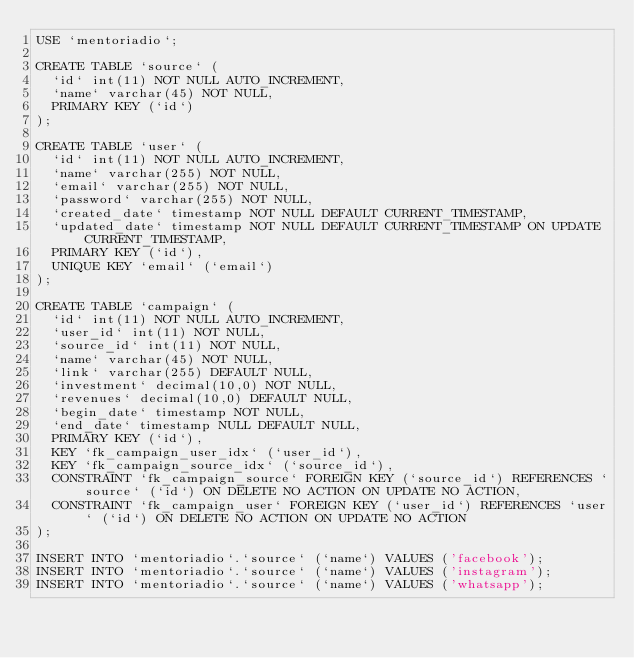Convert code to text. <code><loc_0><loc_0><loc_500><loc_500><_SQL_>USE `mentoriadio`;

CREATE TABLE `source` (
  `id` int(11) NOT NULL AUTO_INCREMENT,
  `name` varchar(45) NOT NULL,
  PRIMARY KEY (`id`)
);

CREATE TABLE `user` (
  `id` int(11) NOT NULL AUTO_INCREMENT,
  `name` varchar(255) NOT NULL,
  `email` varchar(255) NOT NULL,
  `password` varchar(255) NOT NULL,
  `created_date` timestamp NOT NULL DEFAULT CURRENT_TIMESTAMP,
  `updated_date` timestamp NOT NULL DEFAULT CURRENT_TIMESTAMP ON UPDATE CURRENT_TIMESTAMP,
  PRIMARY KEY (`id`),
  UNIQUE KEY `email` (`email`)
);

CREATE TABLE `campaign` (
  `id` int(11) NOT NULL AUTO_INCREMENT,
  `user_id` int(11) NOT NULL,
  `source_id` int(11) NOT NULL,
  `name` varchar(45) NOT NULL,
  `link` varchar(255) DEFAULT NULL,
  `investment` decimal(10,0) NOT NULL,
  `revenues` decimal(10,0) DEFAULT NULL,
  `begin_date` timestamp NOT NULL,
  `end_date` timestamp NULL DEFAULT NULL,
  PRIMARY KEY (`id`),
  KEY `fk_campaign_user_idx` (`user_id`),
  KEY `fk_campaign_source_idx` (`source_id`),
  CONSTRAINT `fk_campaign_source` FOREIGN KEY (`source_id`) REFERENCES `source` (`id`) ON DELETE NO ACTION ON UPDATE NO ACTION,
  CONSTRAINT `fk_campaign_user` FOREIGN KEY (`user_id`) REFERENCES `user` (`id`) ON DELETE NO ACTION ON UPDATE NO ACTION
);

INSERT INTO `mentoriadio`.`source` (`name`) VALUES ('facebook');
INSERT INTO `mentoriadio`.`source` (`name`) VALUES ('instagram');
INSERT INTO `mentoriadio`.`source` (`name`) VALUES ('whatsapp');
</code> 